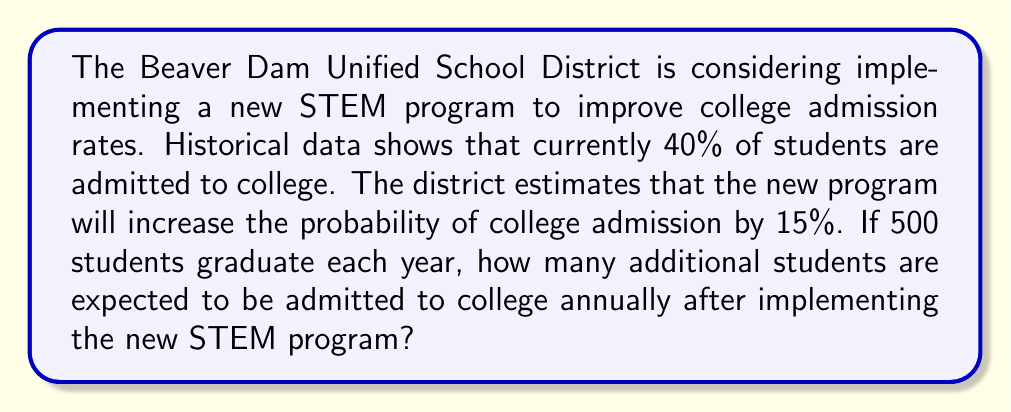Provide a solution to this math problem. Let's approach this step-by-step:

1. Define the variables:
   $p_1$ = current probability of college admission = 40% = 0.40
   $p_2$ = new probability of college admission after STEM program
   $n$ = number of graduating students per year = 500

2. Calculate the new probability of college admission:
   $p_2 = p_1 + 0.15 = 0.40 + 0.15 = 0.55$ or 55%

3. Calculate the expected number of students admitted before the program:
   $E_1 = n \times p_1 = 500 \times 0.40 = 200$ students

4. Calculate the expected number of students admitted after the program:
   $E_2 = n \times p_2 = 500 \times 0.55 = 275$ students

5. Calculate the difference:
   $\Delta E = E_2 - E_1 = 275 - 200 = 75$ students

Therefore, an additional 75 students are expected to be admitted to college annually after implementing the new STEM program.
Answer: 75 students 